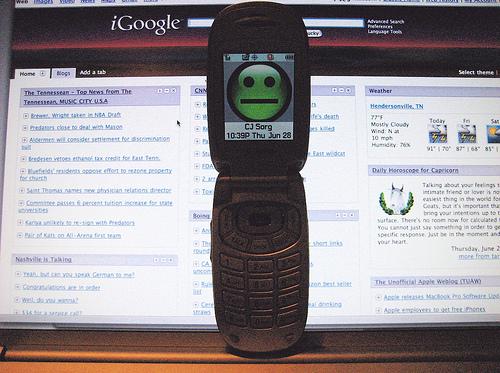What is on the screen of the phone?
Concise answer only. Emoticon. What search engine is being used?
Quick response, please. Google. Is this phone an android?
Be succinct. No. 